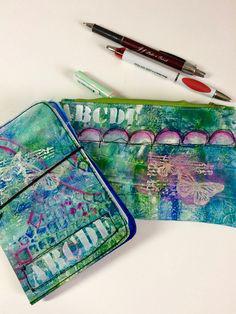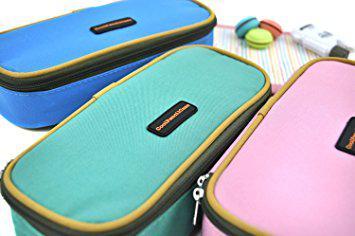The first image is the image on the left, the second image is the image on the right. For the images shown, is this caption "There is one pink case in the image on the left." true? Answer yes or no. No. 